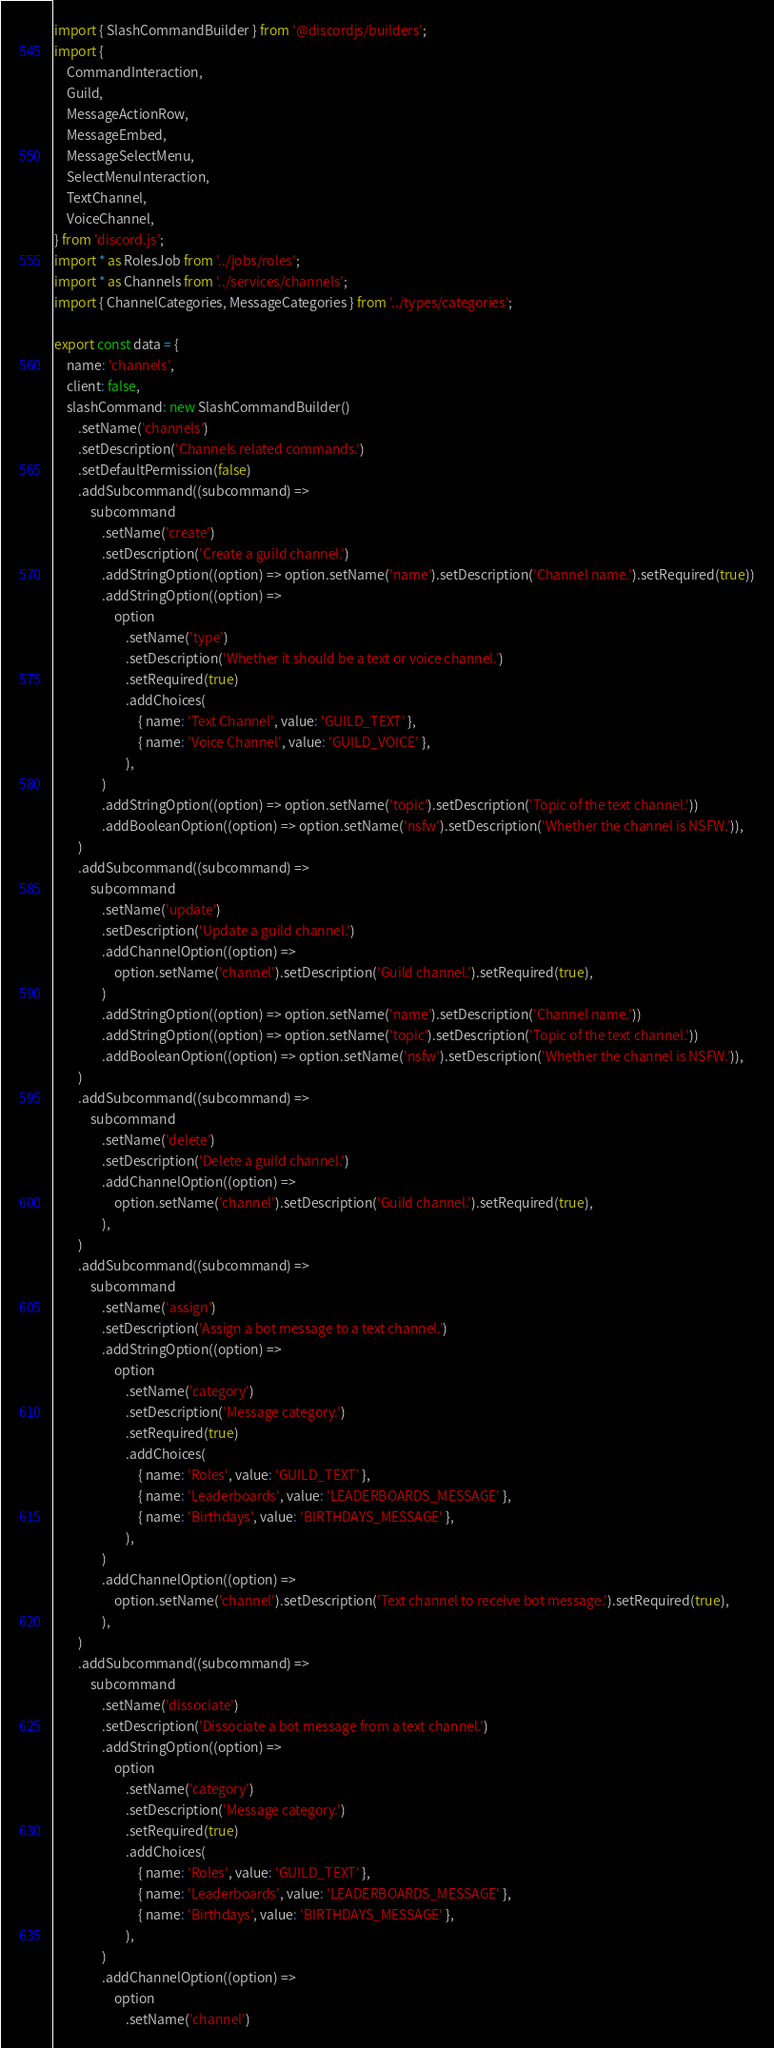Convert code to text. <code><loc_0><loc_0><loc_500><loc_500><_TypeScript_>import { SlashCommandBuilder } from '@discordjs/builders';
import {
	CommandInteraction,
	Guild,
	MessageActionRow,
	MessageEmbed,
	MessageSelectMenu,
	SelectMenuInteraction,
	TextChannel,
	VoiceChannel,
} from 'discord.js';
import * as RolesJob from '../jobs/roles';
import * as Channels from '../services/channels';
import { ChannelCategories, MessageCategories } from '../types/categories';

export const data = {
	name: 'channels',
	client: false,
	slashCommand: new SlashCommandBuilder()
		.setName('channels')
		.setDescription('Channels related commands.')
		.setDefaultPermission(false)
		.addSubcommand((subcommand) =>
			subcommand
				.setName('create')
				.setDescription('Create a guild channel.')
				.addStringOption((option) => option.setName('name').setDescription('Channel name.').setRequired(true))
				.addStringOption((option) =>
					option
						.setName('type')
						.setDescription('Whether it should be a text or voice channel.')
						.setRequired(true)
						.addChoices(
							{ name: 'Text Channel', value: 'GUILD_TEXT' },
							{ name: 'Voice Channel', value: 'GUILD_VOICE' },
						),
				)
				.addStringOption((option) => option.setName('topic').setDescription('Topic of the text channel.'))
				.addBooleanOption((option) => option.setName('nsfw').setDescription('Whether the channel is NSFW.')),
		)
		.addSubcommand((subcommand) =>
			subcommand
				.setName('update')
				.setDescription('Update a guild channel.')
				.addChannelOption((option) =>
					option.setName('channel').setDescription('Guild channel.').setRequired(true),
				)
				.addStringOption((option) => option.setName('name').setDescription('Channel name.'))
				.addStringOption((option) => option.setName('topic').setDescription('Topic of the text channel.'))
				.addBooleanOption((option) => option.setName('nsfw').setDescription('Whether the channel is NSFW.')),
		)
		.addSubcommand((subcommand) =>
			subcommand
				.setName('delete')
				.setDescription('Delete a guild channel.')
				.addChannelOption((option) =>
					option.setName('channel').setDescription('Guild channel.').setRequired(true),
				),
		)
		.addSubcommand((subcommand) =>
			subcommand
				.setName('assign')
				.setDescription('Assign a bot message to a text channel.')
				.addStringOption((option) =>
					option
						.setName('category')
						.setDescription('Message category.')
						.setRequired(true)
						.addChoices(
							{ name: 'Roles', value: 'GUILD_TEXT' },
							{ name: 'Leaderboards', value: 'LEADERBOARDS_MESSAGE' },
							{ name: 'Birthdays', value: 'BIRTHDAYS_MESSAGE' },
						),
				)
				.addChannelOption((option) =>
					option.setName('channel').setDescription('Text channel to receive bot message.').setRequired(true),
				),
		)
		.addSubcommand((subcommand) =>
			subcommand
				.setName('dissociate')
				.setDescription('Dissociate a bot message from a text channel.')
				.addStringOption((option) =>
					option
						.setName('category')
						.setDescription('Message category.')
						.setRequired(true)
						.addChoices(
							{ name: 'Roles', value: 'GUILD_TEXT' },
							{ name: 'Leaderboards', value: 'LEADERBOARDS_MESSAGE' },
							{ name: 'Birthdays', value: 'BIRTHDAYS_MESSAGE' },
						),
				)
				.addChannelOption((option) =>
					option
						.setName('channel')</code> 